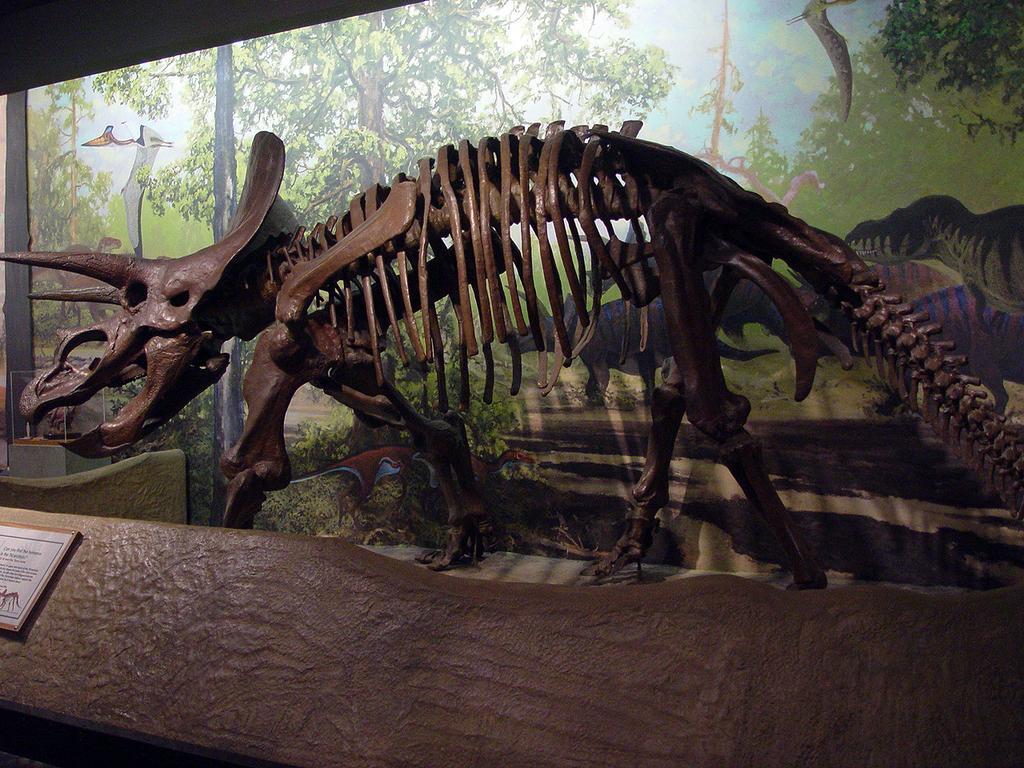Could you give a brief overview of what you see in this image? In this picture there is a skeleton of a dinosaur in the center of the image and there is a poster in the background area of the image. 